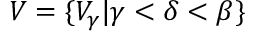Convert formula to latex. <formula><loc_0><loc_0><loc_500><loc_500>V = \{ V _ { \gamma } | \gamma < \delta < \beta \}</formula> 